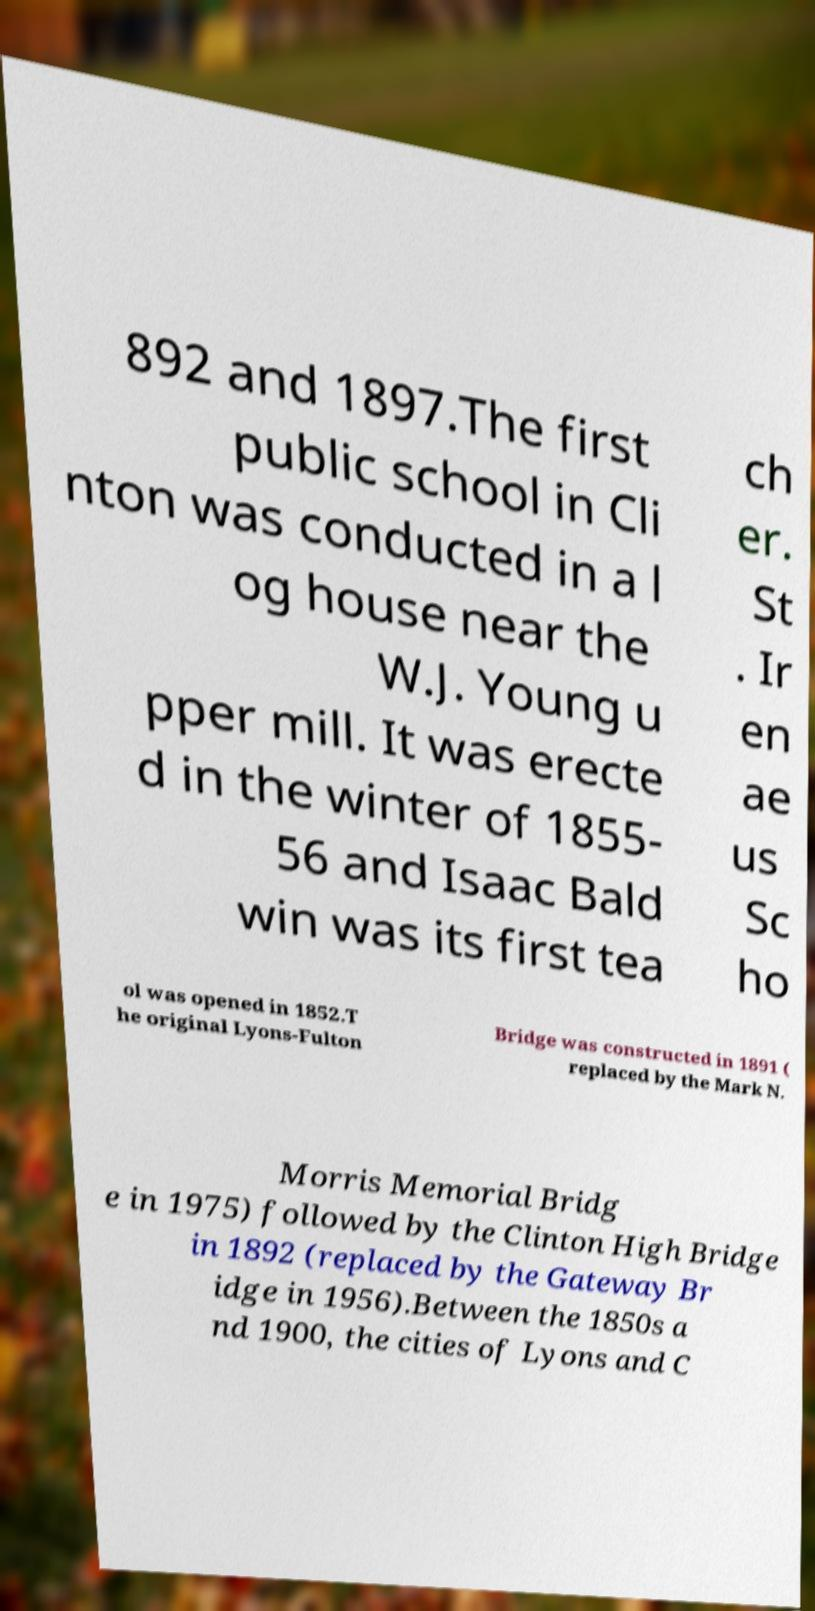What messages or text are displayed in this image? I need them in a readable, typed format. 892 and 1897.The first public school in Cli nton was conducted in a l og house near the W.J. Young u pper mill. It was erecte d in the winter of 1855- 56 and Isaac Bald win was its first tea ch er. St . Ir en ae us Sc ho ol was opened in 1852.T he original Lyons-Fulton Bridge was constructed in 1891 ( replaced by the Mark N. Morris Memorial Bridg e in 1975) followed by the Clinton High Bridge in 1892 (replaced by the Gateway Br idge in 1956).Between the 1850s a nd 1900, the cities of Lyons and C 